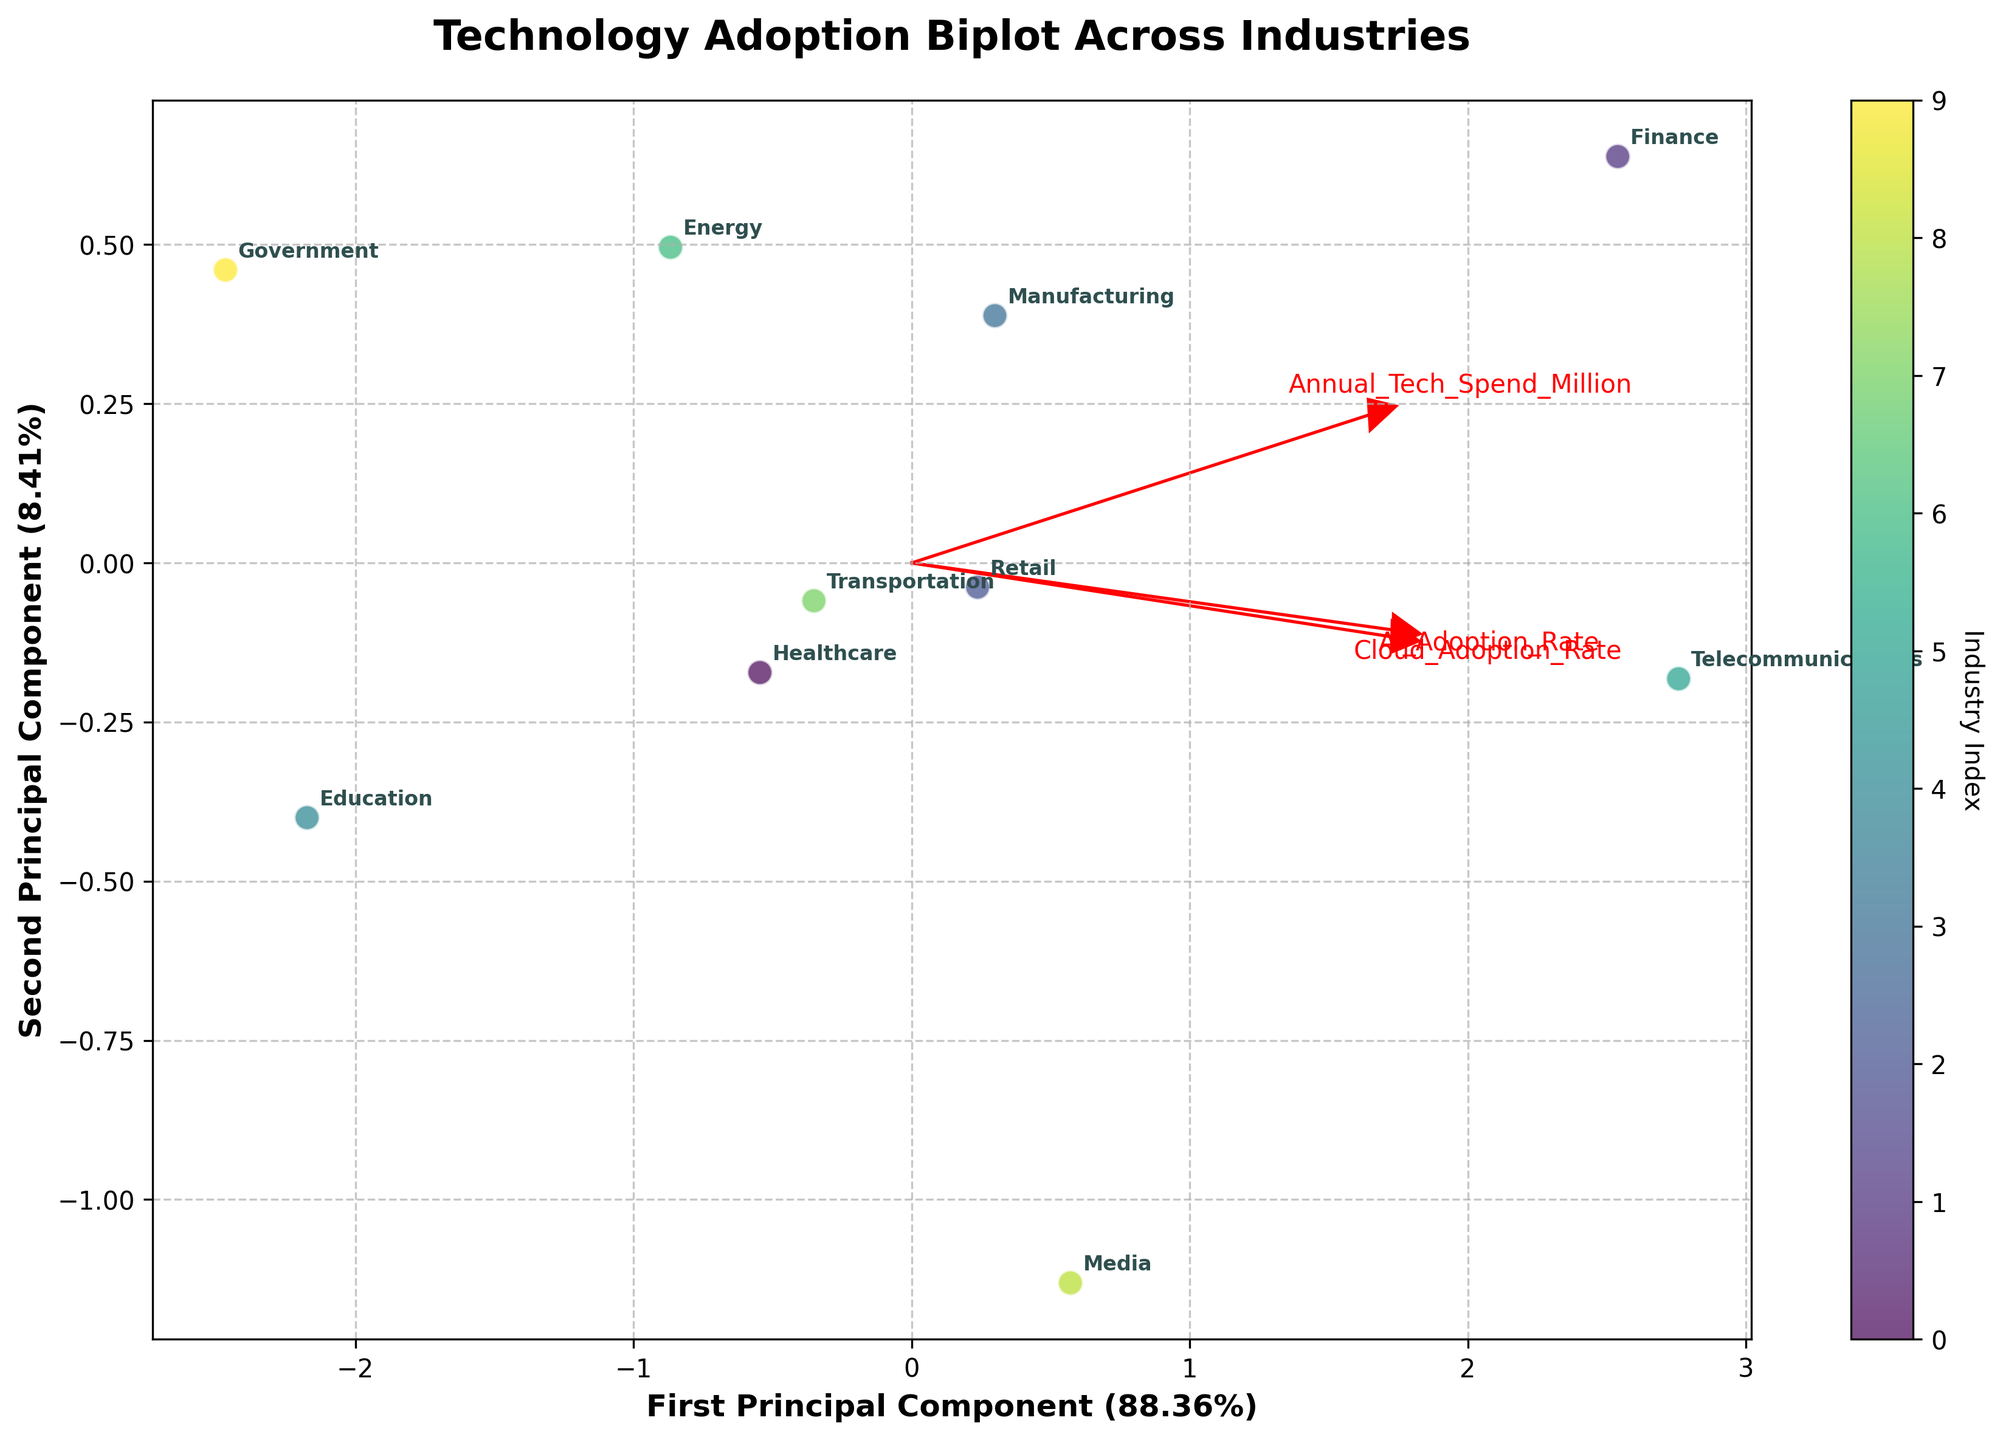What's the title of the figure? The title of the figure is usually placed at the top and is generally descriptive.
Answer: Technology Adoption Biplot Across Industries How many principal components are used in the plot? We can determine the number of principal components by examining the axes labels. This plot has two axes labeled "First Principal Component" and "Second Principal Component," indicating two principal components are used.
Answer: 2 Which industry has the highest Cloud Adoption Rate? To find the industry with the highest Cloud Adoption Rate, find the arrow pointing to "Cloud_Adoption_Rate" and look at the industry positioned furthest in its direction.
Answer: Telecommunications What percentage of the total variation is explained by the first principal component? Look at the x-axis label, which indicates the percentage of the total variation explained by the first principal component inside parentheses.
Answer: Around 56% (The exact value should be derived from the x-axis label but approximate here) Which two industries are closest to each other in the Principal Component space? Closest industries can be identified by looking at the data points and their positions relative to each other. The two points most near to each other represent the industries that are closest in the Principal Component space.
Answer: Transportation and Manufacturing What major conclusion can we draw from the direction of the "AI_Adoption_Rate" arrow? The direction of the "AI_Adoption_Rate" arrow indicates how much AI adoption rates affect industries' overall technology adoption profiles. Industries placed along this vector are strongly influenced by their AI Adoption Rates.
Answer: AI adoption rates significantly impact the placement of industries like Finance and Telecommunications Identify an industry with a lower than average Annual Tech Spend but high cloud and AI adoption rates. Identify the point with lower Annual Tech Spend and high values on the "Cloud_Adoption_Rate" and "AI_Adoption_Rate" from the biplot. This is achieved by its position relative to the vectors.
Answer: Media Which industry has both the lowest AI and Cloud Adoption Rates? Identify the point that is positioned furthest from both the "AI_Adoption_Rate" and "Cloud_Adoption_Rate" vectors. This represents the industry with the lowest rates.
Answer: Government 